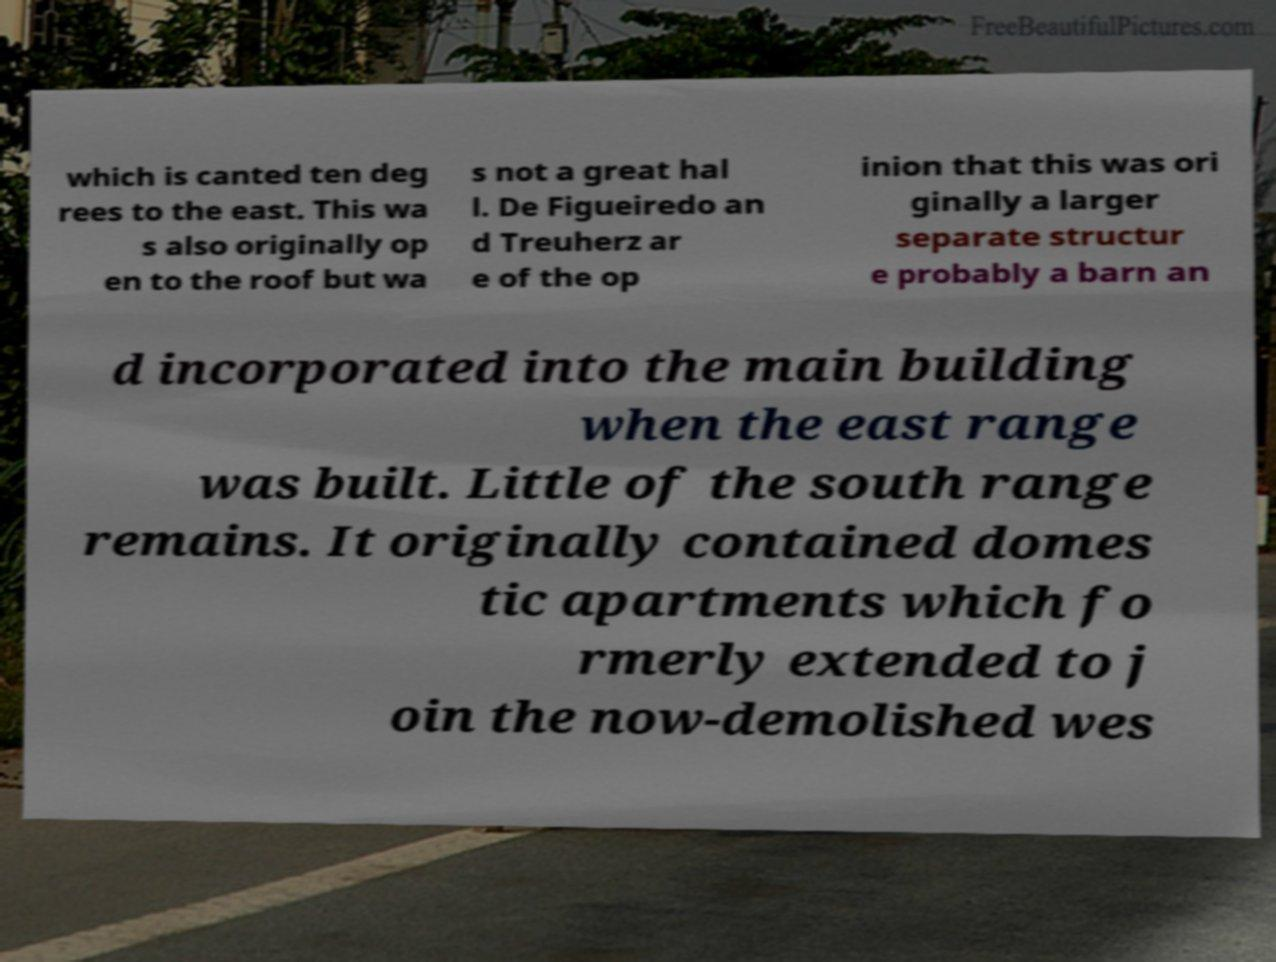Please identify and transcribe the text found in this image. which is canted ten deg rees to the east. This wa s also originally op en to the roof but wa s not a great hal l. De Figueiredo an d Treuherz ar e of the op inion that this was ori ginally a larger separate structur e probably a barn an d incorporated into the main building when the east range was built. Little of the south range remains. It originally contained domes tic apartments which fo rmerly extended to j oin the now-demolished wes 